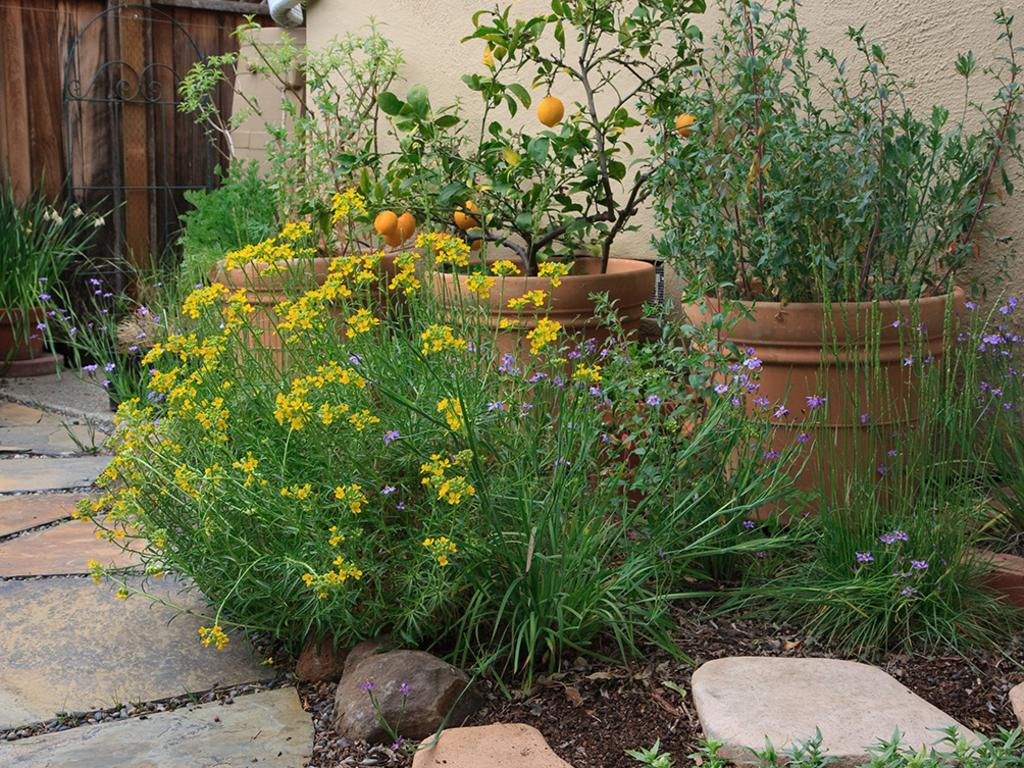What type of vegetation can be seen in the image? There are plants in the image. Where are the plants located in the area? The plants are present all over the area. What other elements can be seen in the image besides plants? There are stones visible in the image. What additional features can be observed on the plants? Flowers and fruits are present on the plants. How many pages of juice can be seen in the image? There is no juice present in the image. 